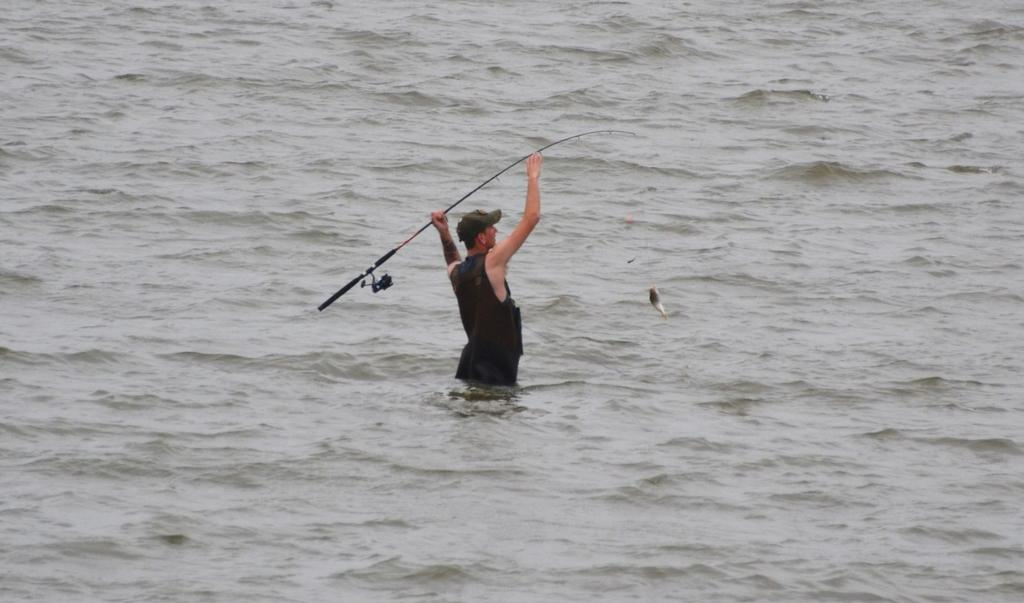Who is present in the image? There is a man in the image. What is the man doing in the image? The man is in the water and holding a fish rod. What might the man be trying to catch in the water? The man might be trying to catch a fish with the fish rod. What type of game is the man playing in the image? There is no game being played in the image; the man is fishing with a fish rod. What toy is the man holding in the image? The man is not holding a toy; he is holding a fish rod. 